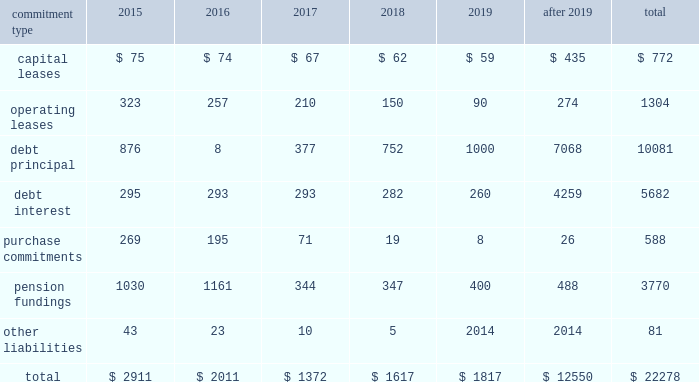United parcel service , inc .
And subsidiaries management's discussion and analysis of financial condition and results of operations issuances of debt in 2014 and 2013 consisted primarily of longer-maturity commercial paper .
Issuances of debt in 2012 consisted primarily of senior fixed rate note offerings totaling $ 1.75 billion .
Repayments of debt in 2014 and 2013 consisted primarily of the maturity of our $ 1.0 and $ 1.75 billion senior fixed rate notes that matured in april 2014 and january 2013 , respectively .
The remaining repayments of debt during the 2012 through 2014 time period included paydowns of commercial paper and scheduled principal payments on our capitalized lease obligations .
We consider the overall fixed and floating interest rate mix of our portfolio and the related overall cost of borrowing when planning for future issuances and non-scheduled repayments of debt .
We had $ 772 million of commercial paper outstanding at december 31 , 2014 , and no commercial paper outstanding at december 31 , 2013 and 2012 .
The amount of commercial paper outstanding fluctuates throughout each year based on daily liquidity needs .
The average commercial paper balance was $ 1.356 billion and the average interest rate paid was 0.10% ( 0.10 % ) in 2014 ( $ 1.013 billion and 0.07% ( 0.07 % ) in 2013 , and $ 962 million and 0.07% ( 0.07 % ) in 2012 , respectively ) .
The variation in cash received from common stock issuances to employees was primarily due to level of stock option exercises in the 2012 through 2014 period .
The cash outflows in other financing activities were impacted by several factors .
Cash inflows ( outflows ) from the premium payments and settlements of capped call options for the purchase of ups class b shares were $ ( 47 ) , $ ( 93 ) and $ 206 million for 2014 , 2013 and 2012 , respectively .
Cash outflows related to the repurchase of shares to satisfy tax withholding obligations on vested employee stock awards were $ 224 , $ 253 and $ 234 million for 2014 , 2013 and 2012 , respectively .
In 2013 , we paid $ 70 million to purchase the noncontrolling interest in a joint venture that operates in the middle east , turkey and portions of the central asia region .
In 2012 , we settled several interest rate derivatives that were designated as hedges of the senior fixed-rate debt offerings that year , which resulted in a cash outflow of $ 70 million .
Sources of credit see note 7 to the audited consolidated financial statements for a discussion of our available credit and debt covenants .
Guarantees and other off-balance sheet arrangements we do not have guarantees or other off-balance sheet financing arrangements , including variable interest entities , which we believe could have a material impact on financial condition or liquidity .
Contractual commitments we have contractual obligations and commitments in the form of capital leases , operating leases , debt obligations , purchase commitments , and certain other liabilities .
We intend to satisfy these obligations through the use of cash flow from operations .
The table summarizes the expected cash outflow to satisfy our contractual obligations and commitments as of december 31 , 2014 ( in millions ) : .

What percent of total expected cash outflow to satisfy contractual obligations and commitments as of december 31 , 2014 , is debt principal? 
Computations: (10081 / 22278)
Answer: 0.45251. 